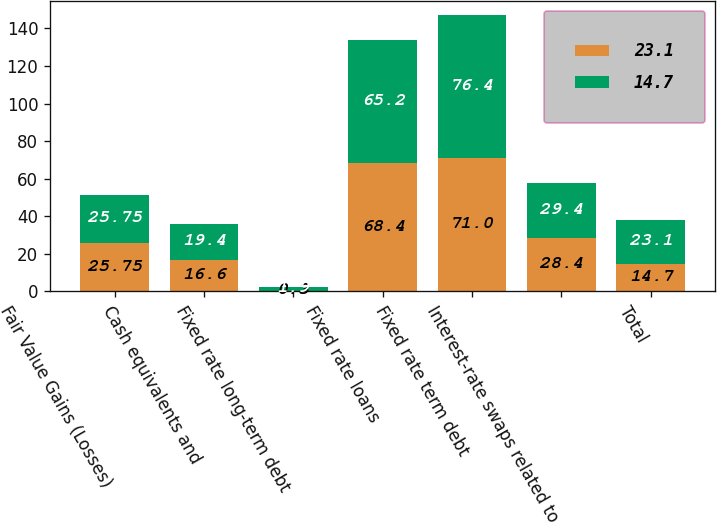Convert chart. <chart><loc_0><loc_0><loc_500><loc_500><stacked_bar_chart><ecel><fcel>Fair Value Gains (Losses)<fcel>Cash equivalents and<fcel>Fixed rate long-term debt<fcel>Fixed rate loans<fcel>Fixed rate term debt<fcel>Interest-rate swaps related to<fcel>Total<nl><fcel>23.1<fcel>25.75<fcel>16.6<fcel>0.3<fcel>68.4<fcel>71<fcel>28.4<fcel>14.7<nl><fcel>14.7<fcel>25.75<fcel>19.4<fcel>1.9<fcel>65.2<fcel>76.4<fcel>29.4<fcel>23.1<nl></chart> 